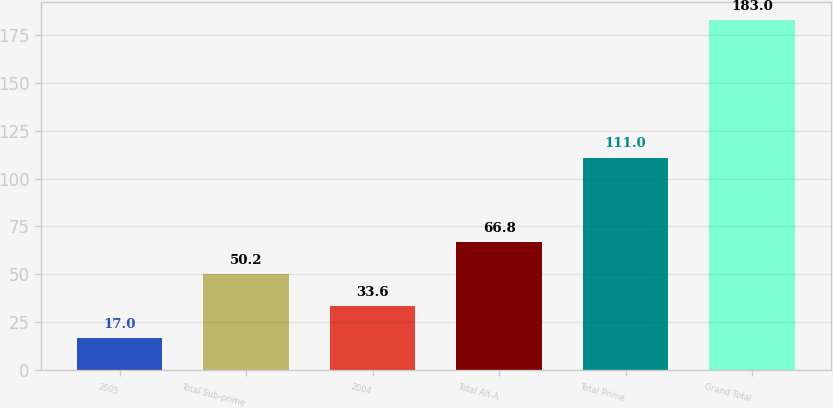<chart> <loc_0><loc_0><loc_500><loc_500><bar_chart><fcel>2005<fcel>Total Sub-prime<fcel>2004<fcel>Total Alt-A<fcel>Total Prime<fcel>Grand Total<nl><fcel>17<fcel>50.2<fcel>33.6<fcel>66.8<fcel>111<fcel>183<nl></chart> 